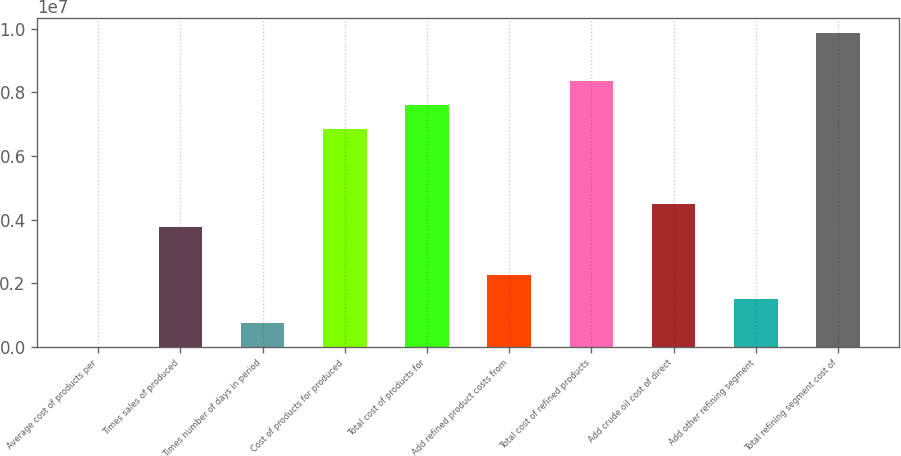<chart> <loc_0><loc_0><loc_500><loc_500><bar_chart><fcel>Average cost of products per<fcel>Times sales of produced<fcel>Times number of days in period<fcel>Cost of products for produced<fcel>Total cost of products for<fcel>Add refined product costs from<fcel>Total cost of refined products<fcel>Add crude oil cost of direct<fcel>Add other refining segment<fcel>Total refining segment cost of<nl><fcel>82.27<fcel>3.75522e+06<fcel>751110<fcel>6.85071e+06<fcel>7.60174e+06<fcel>2.25316e+06<fcel>8.35277e+06<fcel>4.50625e+06<fcel>1.50214e+06<fcel>9.85482e+06<nl></chart> 